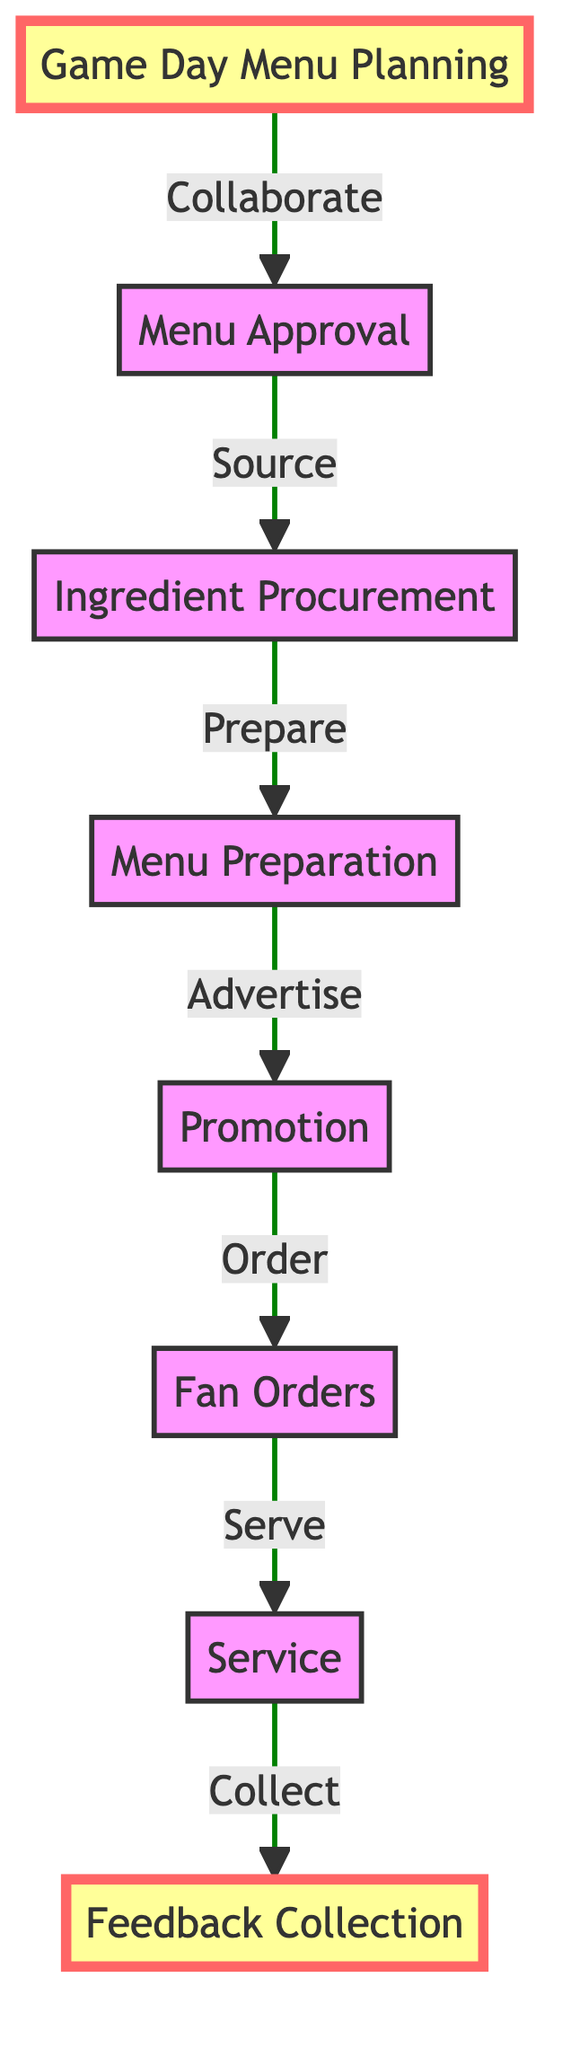What is the first step in the game day menu process? The diagram indicates that the first step is "Game Day Menu Planning," which is the starting point of the flow.
Answer: Game Day Menu Planning How many nodes are present in the diagram? Counting each distinct step visually represented, there are a total of eight nodes identified in the flowchart.
Answer: 8 What action follows menu approval? According to the diagram, the action that follows "Menu Approval" is "Ingredient Procurement."
Answer: Ingredient Procurement What step comes before "Service"? The step preceding "Service" is "Fan Orders" as it directly leads into the service of the meals.
Answer: Fan Orders Which node is highlighted at the start and end of the flow? The nodes highlighted in the diagram at both the beginning and the end are "Game Day Menu Planning" and "Feedback Collection."
Answer: Game Day Menu Planning and Feedback Collection What type of action takes place after promoting the menu? Following the "Promotion" step, the action that takes place is the "Order" from fans.
Answer: Order Which step is responsible for collecting feedback? The diagram clearly shows that "Feedback Collection" is the final step responsible for gathering fan feedback after the service.
Answer: Feedback Collection What is the relationship between "Promotion" and "Fan Orders"? The relationship indicates that after "Promotion," the "Fan Orders" are then taken, showcasing a direct flow from advertising to ordering.
Answer: Promotion to Fan Orders What process occurs before menu preparation? Before "Menu Preparation," the necessary step is "Ingredient Procurement," which involves sourcing the ingredients needed for the menu items.
Answer: Ingredient Procurement 